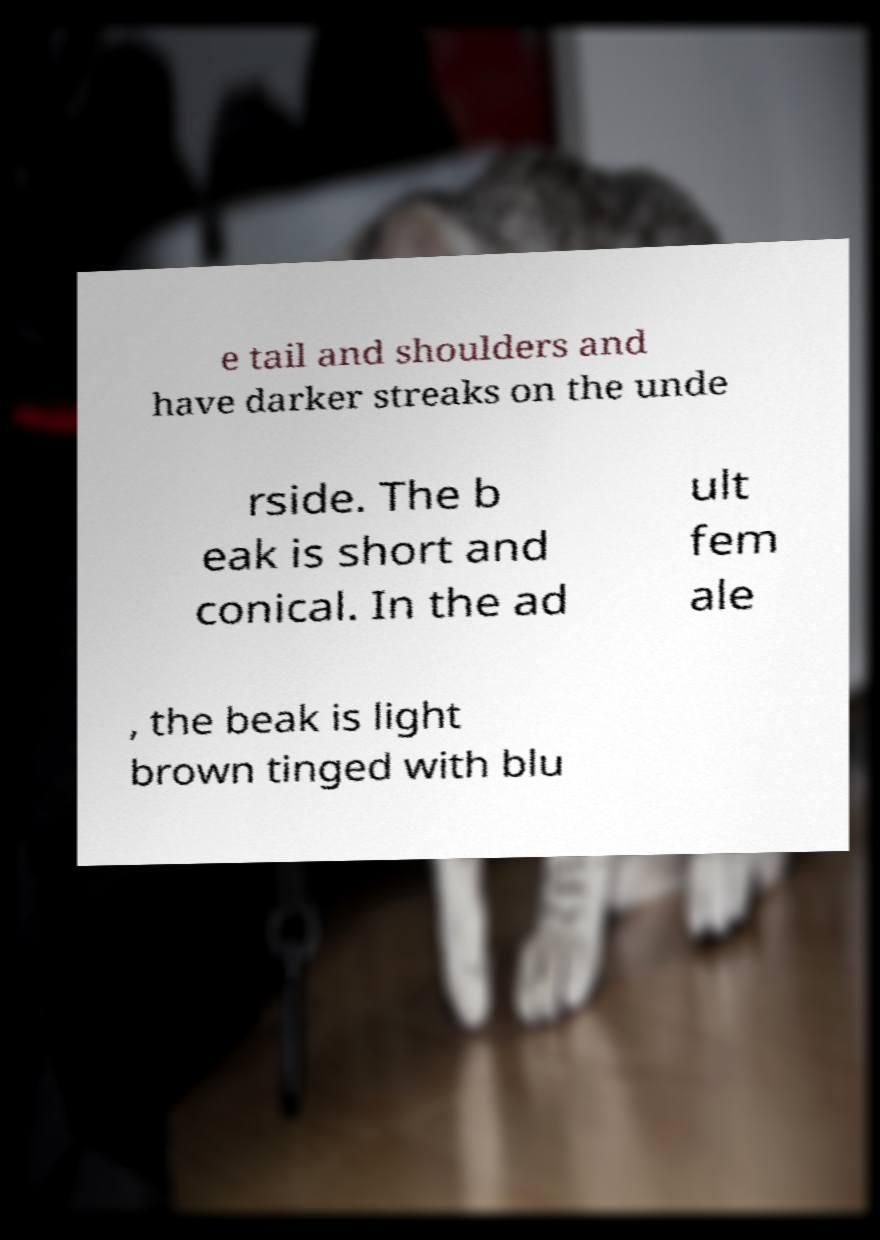What messages or text are displayed in this image? I need them in a readable, typed format. e tail and shoulders and have darker streaks on the unde rside. The b eak is short and conical. In the ad ult fem ale , the beak is light brown tinged with blu 